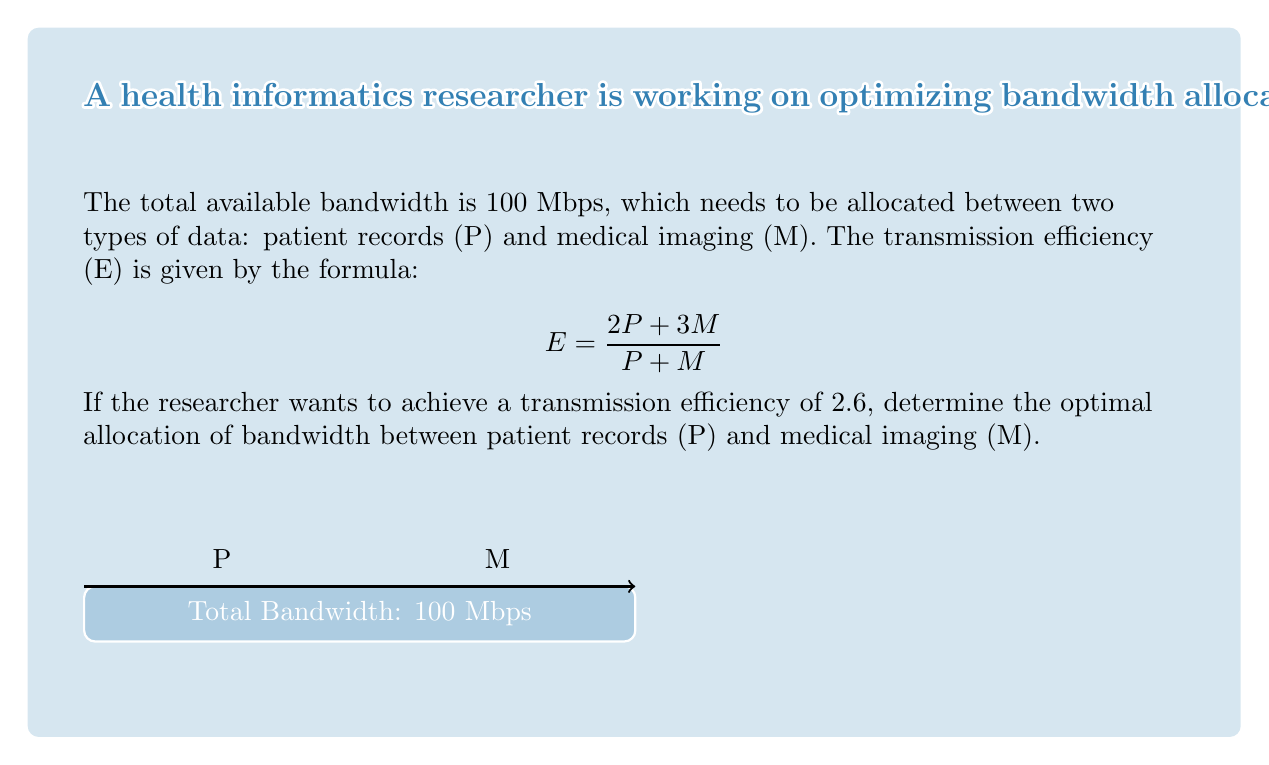Provide a solution to this math problem. Let's solve this step-by-step:

1) We start with the efficiency formula:
   $$E = \frac{2P + 3M}{P + M}$$

2) We're told that the desired efficiency is 2.6, so we can set up the equation:
   $$2.6 = \frac{2P + 3M}{P + M}$$

3) Cross-multiply to eliminate the fraction:
   $$2.6(P + M) = 2P + 3M$$
   $$2.6P + 2.6M = 2P + 3M$$

4) Distribute on the left side:
   $$2.6P + 2.6M = 2P + 3M$$

5) Subtract 2P from both sides:
   $$0.6P + 2.6M = 3M$$

6) Subtract 2.6M from both sides:
   $$0.6P = 0.4M$$

7) Divide both sides by 0.6:
   $$P = \frac{2}{3}M$$

8) We know that the total bandwidth is 100 Mbps, so:
   $$P + M = 100$$

9) Substitute the expression for P from step 7:
   $$\frac{2}{3}M + M = 100$$
   $$\frac{5}{3}M = 100$$

10) Multiply both sides by 3/5:
    $$M = 60$$

11) If M = 60, then P = 100 - 60 = 40

Therefore, the optimal allocation is 40 Mbps for patient records (P) and 60 Mbps for medical imaging (M).
Answer: P = 40 Mbps, M = 60 Mbps 